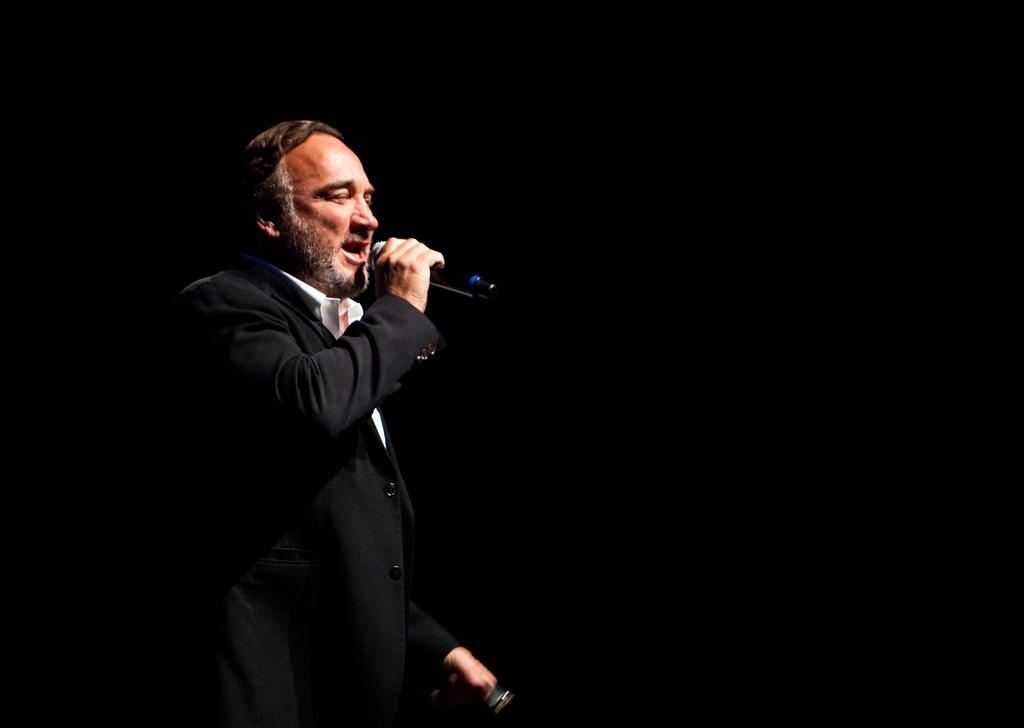Who is the main subject in the image? There is a man in the image. Where is the man positioned in the image? The man is standing in the middle of the image. What is the man holding in the image? The man is holding a microphone. What is the man doing in the image? The man is speaking. What type of car is the man saying good-bye to in the image? There is no car present in the image, and the man is not saying good-bye. 